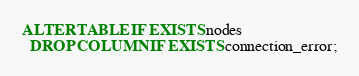Convert code to text. <code><loc_0><loc_0><loc_500><loc_500><_SQL_>ALTER TABLE IF EXISTS nodes
  DROP COLUMN IF EXISTS connection_error;</code> 